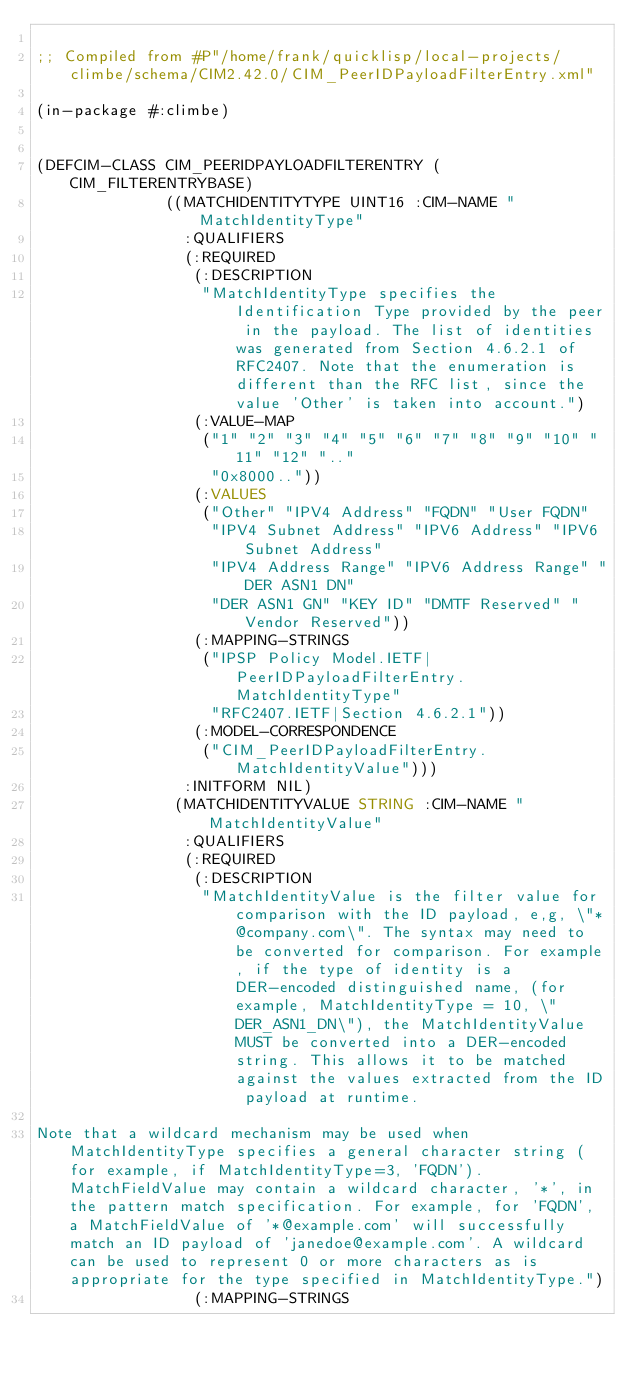Convert code to text. <code><loc_0><loc_0><loc_500><loc_500><_Lisp_>
;; Compiled from #P"/home/frank/quicklisp/local-projects/climbe/schema/CIM2.42.0/CIM_PeerIDPayloadFilterEntry.xml"

(in-package #:climbe)


(DEFCIM-CLASS CIM_PEERIDPAYLOADFILTERENTRY (CIM_FILTERENTRYBASE)
              ((MATCHIDENTITYTYPE UINT16 :CIM-NAME "MatchIdentityType"
                :QUALIFIERS
                (:REQUIRED
                 (:DESCRIPTION
                  "MatchIdentityType specifies the Identification Type provided by the peer in the payload. The list of identities was generated from Section 4.6.2.1 of RFC2407. Note that the enumeration is different than the RFC list, since the value 'Other' is taken into account.")
                 (:VALUE-MAP
                  ("1" "2" "3" "4" "5" "6" "7" "8" "9" "10" "11" "12" ".."
                   "0x8000.."))
                 (:VALUES
                  ("Other" "IPV4 Address" "FQDN" "User FQDN"
                   "IPV4 Subnet Address" "IPV6 Address" "IPV6 Subnet Address"
                   "IPV4 Address Range" "IPV6 Address Range" "DER ASN1 DN"
                   "DER ASN1 GN" "KEY ID" "DMTF Reserved" "Vendor Reserved"))
                 (:MAPPING-STRINGS
                  ("IPSP Policy Model.IETF|PeerIDPayloadFilterEntry.MatchIdentityType"
                   "RFC2407.IETF|Section 4.6.2.1"))
                 (:MODEL-CORRESPONDENCE
                  ("CIM_PeerIDPayloadFilterEntry.MatchIdentityValue")))
                :INITFORM NIL)
               (MATCHIDENTITYVALUE STRING :CIM-NAME "MatchIdentityValue"
                :QUALIFIERS
                (:REQUIRED
                 (:DESCRIPTION
                  "MatchIdentityValue is the filter value for comparison with the ID payload, e,g, \"*@company.com\". The syntax may need to be converted for comparison. For example, if the type of identity is a DER-encoded distinguished name, (for example, MatchIdentityType = 10, \"DER_ASN1_DN\"), the MatchIdentityValue MUST be converted into a DER-encoded string. This allows it to be matched against the values extracted from the ID payload at runtime. 

Note that a wildcard mechanism may be used when MatchIdentityType specifies a general character string (for example, if MatchIdentityType=3, 'FQDN'). MatchFieldValue may contain a wildcard character, '*', in the pattern match specification. For example, for 'FQDN', a MatchFieldValue of '*@example.com' will successfully match an ID payload of 'janedoe@example.com'. A wildcard can be used to represent 0 or more characters as is appropriate for the type specified in MatchIdentityType.")
                 (:MAPPING-STRINGS</code> 